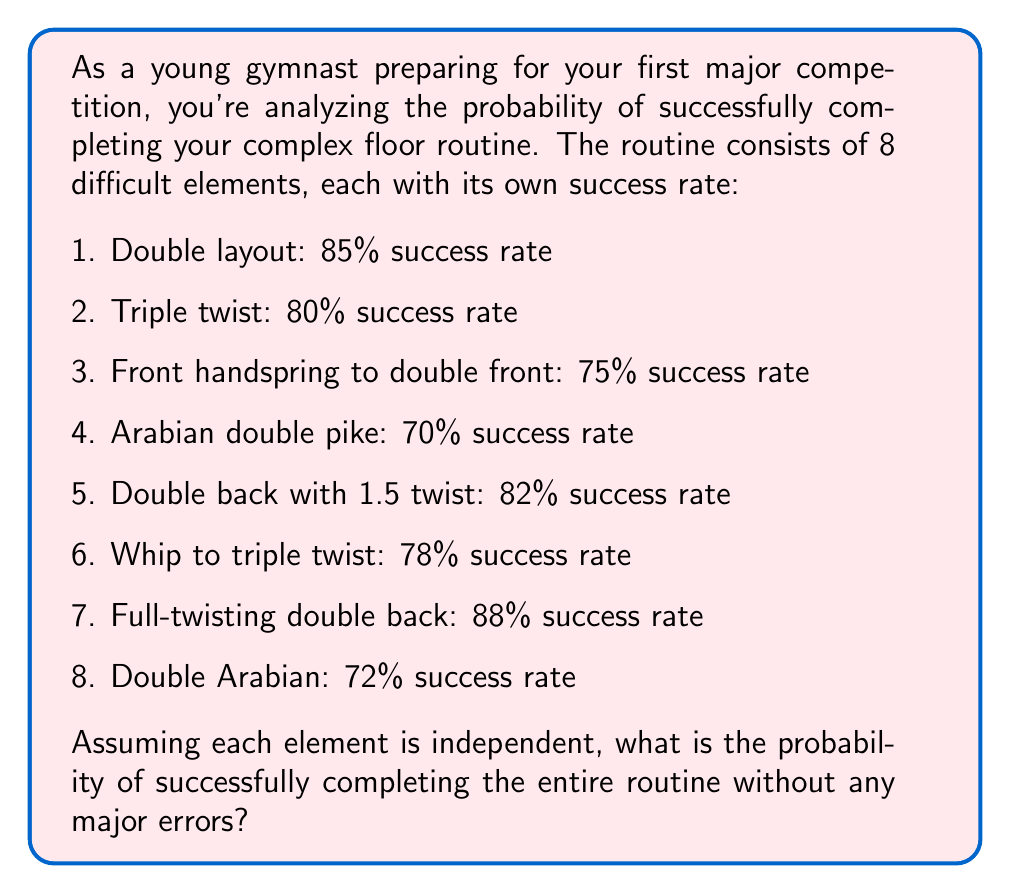Solve this math problem. To solve this problem, we need to follow these steps:

1. Understand that for the entire routine to be successful, each individual element must be successful.
2. Recall that the probability of independent events all occurring is the product of their individual probabilities.
3. Convert the success rates to probabilities (divide by 100).
4. Multiply all the probabilities together.

Let's calculate:

$$\begin{align*}
P(\text{success}) &= 0.85 \times 0.80 \times 0.75 \times 0.70 \times 0.82 \times 0.78 \times 0.88 \times 0.72 \\[2ex]
&= 0.1469678656
\end{align*}$$

To convert this to a percentage:

$$0.1469678656 \times 100\% \approx 14.70\%$$

This result might seem low, but it reflects the difficulty of performing all elements perfectly in a complex routine. It's important to remember that even top gymnasts don't always execute every element perfectly in competition.
Answer: The probability of successfully completing the entire routine without any major errors is approximately 14.70% or 0.1470. 